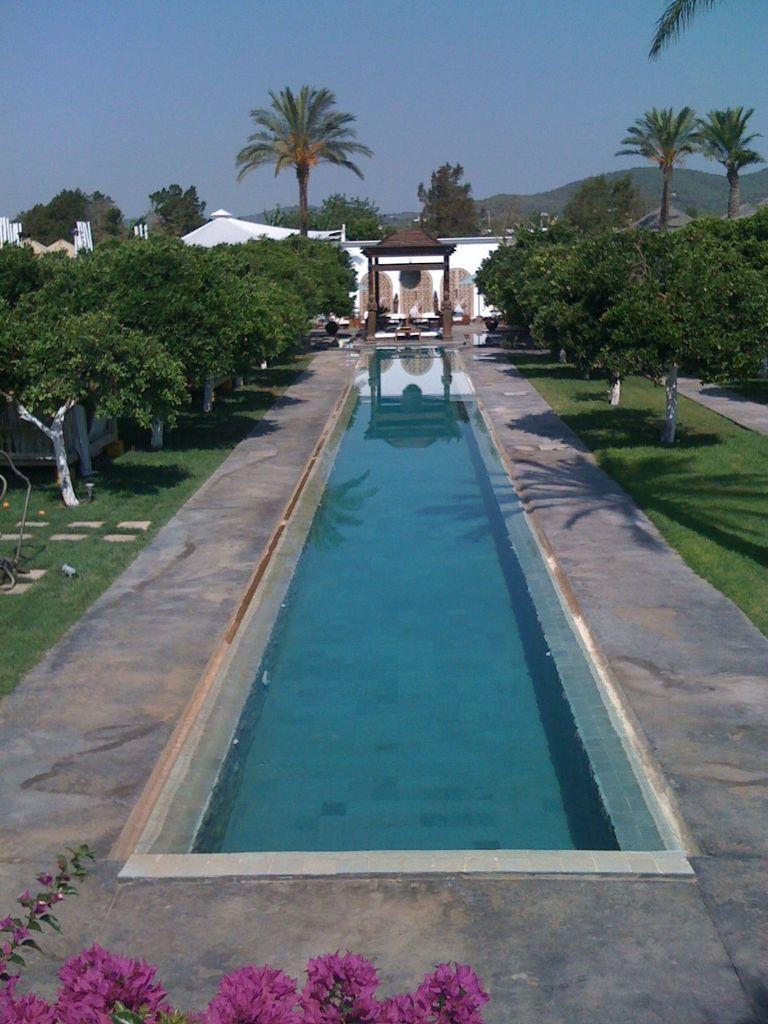In one or two sentences, can you explain what this image depicts? In this image I can see a water pool in the center of the image and a construction in the center of the image and the reflection of the construction in the pool water. I can see trees on both sides of the pool. I can see trees, mountains and sky at the top of the image. 